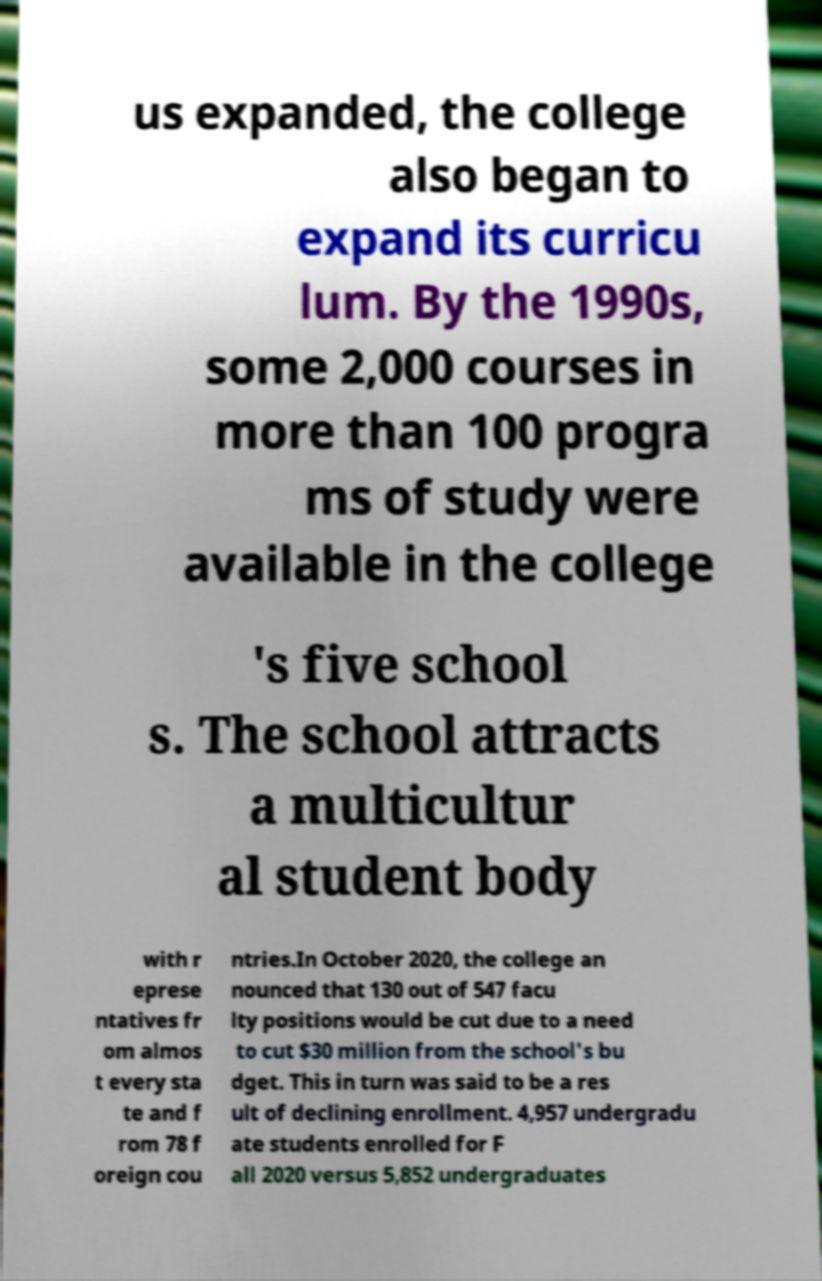For documentation purposes, I need the text within this image transcribed. Could you provide that? us expanded, the college also began to expand its curricu lum. By the 1990s, some 2,000 courses in more than 100 progra ms of study were available in the college 's five school s. The school attracts a multicultur al student body with r eprese ntatives fr om almos t every sta te and f rom 78 f oreign cou ntries.In October 2020, the college an nounced that 130 out of 547 facu lty positions would be cut due to a need to cut $30 million from the school's bu dget. This in turn was said to be a res ult of declining enrollment. 4,957 undergradu ate students enrolled for F all 2020 versus 5,852 undergraduates 